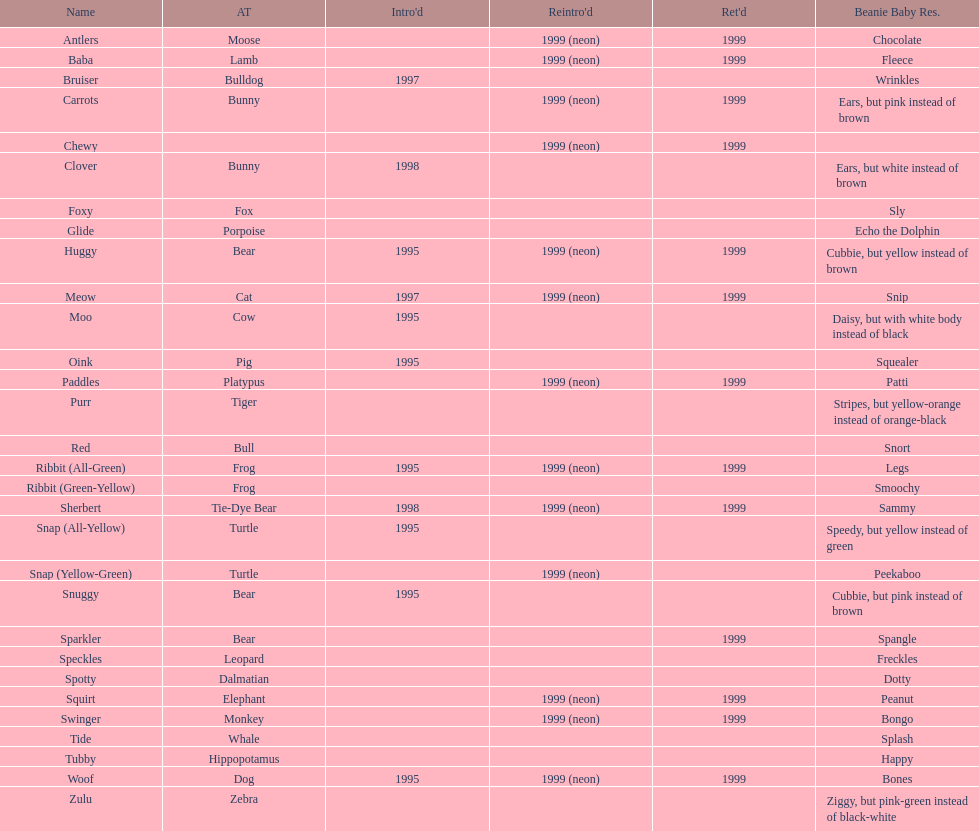Can you parse all the data within this table? {'header': ['Name', 'AT', "Intro'd", "Reintro'd", "Ret'd", 'Beanie Baby Res.'], 'rows': [['Antlers', 'Moose', '', '1999 (neon)', '1999', 'Chocolate'], ['Baba', 'Lamb', '', '1999 (neon)', '1999', 'Fleece'], ['Bruiser', 'Bulldog', '1997', '', '', 'Wrinkles'], ['Carrots', 'Bunny', '', '1999 (neon)', '1999', 'Ears, but pink instead of brown'], ['Chewy', '', '', '1999 (neon)', '1999', ''], ['Clover', 'Bunny', '1998', '', '', 'Ears, but white instead of brown'], ['Foxy', 'Fox', '', '', '', 'Sly'], ['Glide', 'Porpoise', '', '', '', 'Echo the Dolphin'], ['Huggy', 'Bear', '1995', '1999 (neon)', '1999', 'Cubbie, but yellow instead of brown'], ['Meow', 'Cat', '1997', '1999 (neon)', '1999', 'Snip'], ['Moo', 'Cow', '1995', '', '', 'Daisy, but with white body instead of black'], ['Oink', 'Pig', '1995', '', '', 'Squealer'], ['Paddles', 'Platypus', '', '1999 (neon)', '1999', 'Patti'], ['Purr', 'Tiger', '', '', '', 'Stripes, but yellow-orange instead of orange-black'], ['Red', 'Bull', '', '', '', 'Snort'], ['Ribbit (All-Green)', 'Frog', '1995', '1999 (neon)', '1999', 'Legs'], ['Ribbit (Green-Yellow)', 'Frog', '', '', '', 'Smoochy'], ['Sherbert', 'Tie-Dye Bear', '1998', '1999 (neon)', '1999', 'Sammy'], ['Snap (All-Yellow)', 'Turtle', '1995', '', '', 'Speedy, but yellow instead of green'], ['Snap (Yellow-Green)', 'Turtle', '', '1999 (neon)', '', 'Peekaboo'], ['Snuggy', 'Bear', '1995', '', '', 'Cubbie, but pink instead of brown'], ['Sparkler', 'Bear', '', '', '1999', 'Spangle'], ['Speckles', 'Leopard', '', '', '', 'Freckles'], ['Spotty', 'Dalmatian', '', '', '', 'Dotty'], ['Squirt', 'Elephant', '', '1999 (neon)', '1999', 'Peanut'], ['Swinger', 'Monkey', '', '1999 (neon)', '1999', 'Bongo'], ['Tide', 'Whale', '', '', '', 'Splash'], ['Tubby', 'Hippopotamus', '', '', '', 'Happy'], ['Woof', 'Dog', '1995', '1999 (neon)', '1999', 'Bones'], ['Zulu', 'Zebra', '', '', '', 'Ziggy, but pink-green instead of black-white']]} In what year were the first pillow pals introduced? 1995. 